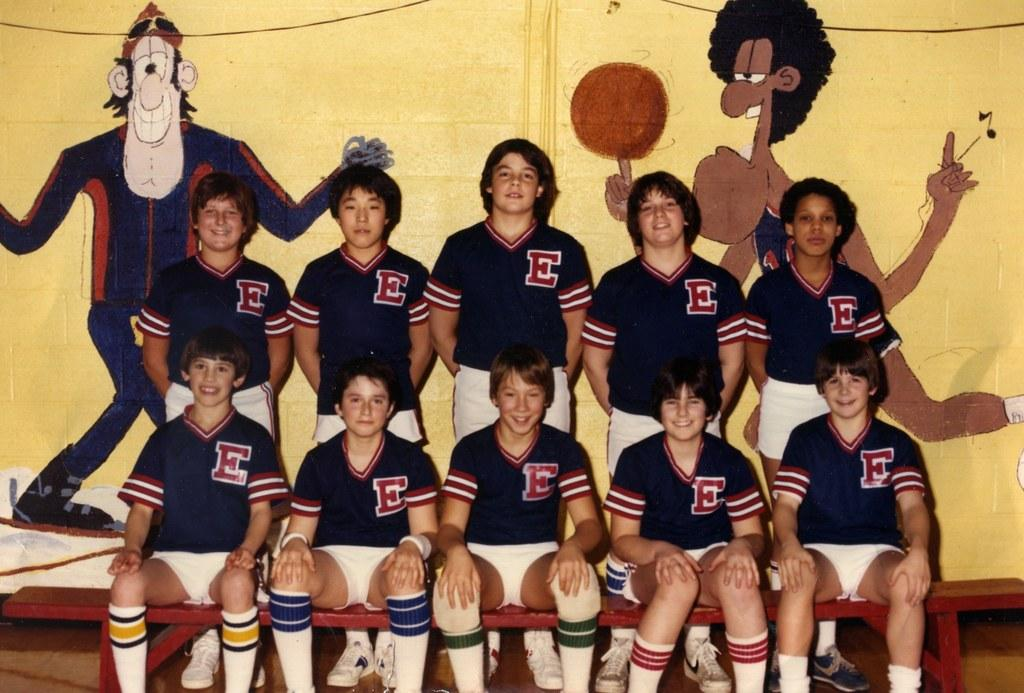<image>
Summarize the visual content of the image. A sports team wearing jerseys that have a big E on them. 